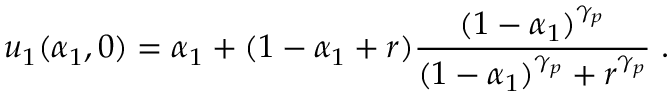<formula> <loc_0><loc_0><loc_500><loc_500>u _ { 1 } ( \alpha _ { 1 } , 0 ) = \alpha _ { 1 } + ( 1 - \alpha _ { 1 } + r ) \frac { ( 1 - \alpha _ { 1 } ) ^ { \gamma _ { p } } } { ( 1 - \alpha _ { 1 } ) ^ { \gamma _ { p } } + r ^ { \gamma _ { p } } } \, .</formula> 